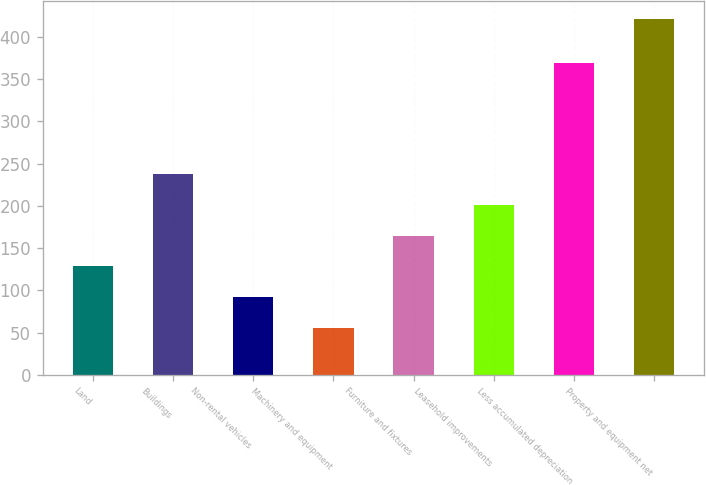Convert chart to OTSL. <chart><loc_0><loc_0><loc_500><loc_500><bar_chart><fcel>Land<fcel>Buildings<fcel>Non-rental vehicles<fcel>Machinery and equipment<fcel>Furniture and fixtures<fcel>Leasehold improvements<fcel>Less accumulated depreciation<fcel>Property and equipment net<nl><fcel>128.2<fcel>238<fcel>91.6<fcel>55<fcel>164.8<fcel>201.4<fcel>369<fcel>421<nl></chart> 